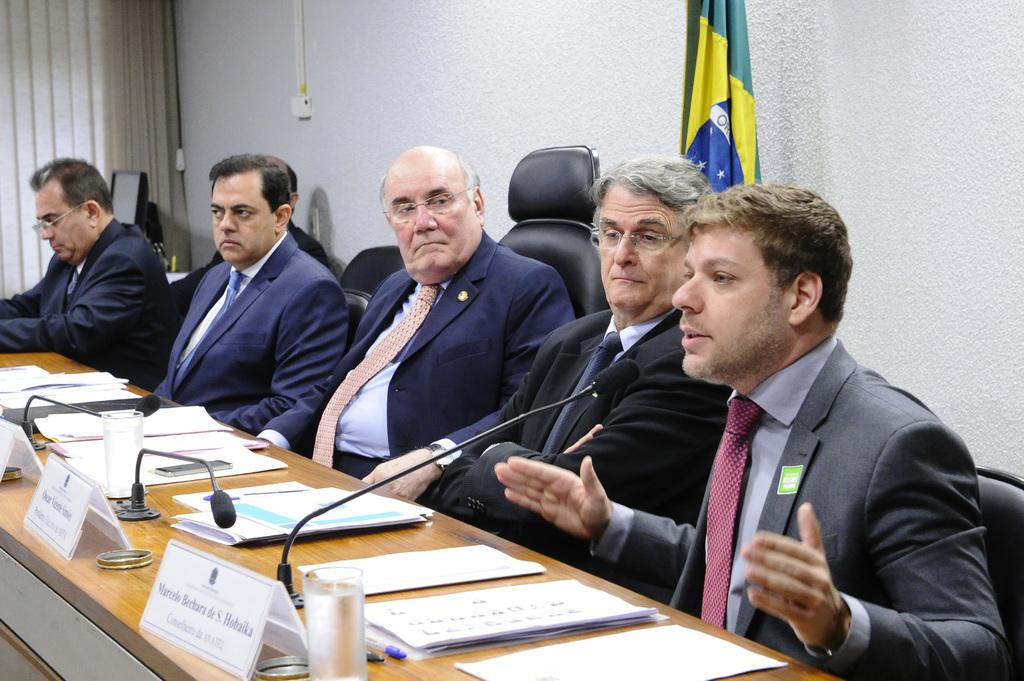What are the men in the image wearing? The men in the image are wearing suits. Where are the men sitting in the image? The men are sitting in front of a table. What objects can be seen on the table? There are microphones, glasses, and papers on the table. What is the flag's location in the image? The flag is in front of a wall. What type of soup is being served in the image? There is no soup present in the image. How do the men in the image express their love for each other? The image does not depict any expressions of love between the men; they are simply sitting at a table with various objects. 